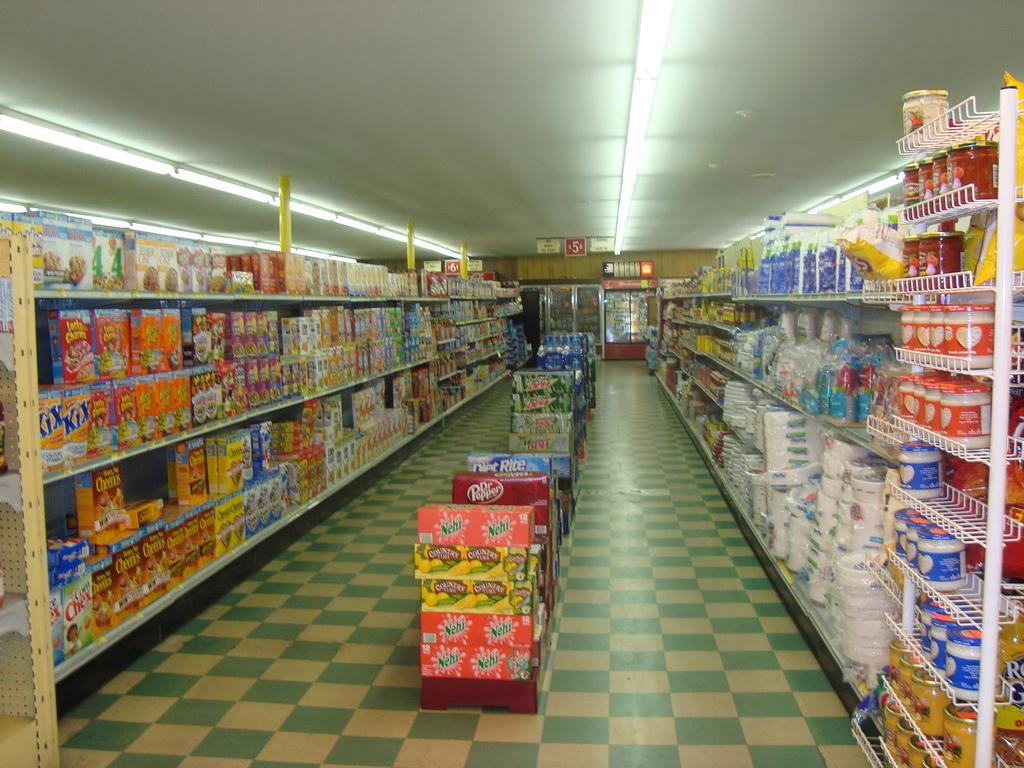<image>
Render a clear and concise summary of the photo. Aisle of a store that sells Nehi and Country Time soda in the front. 